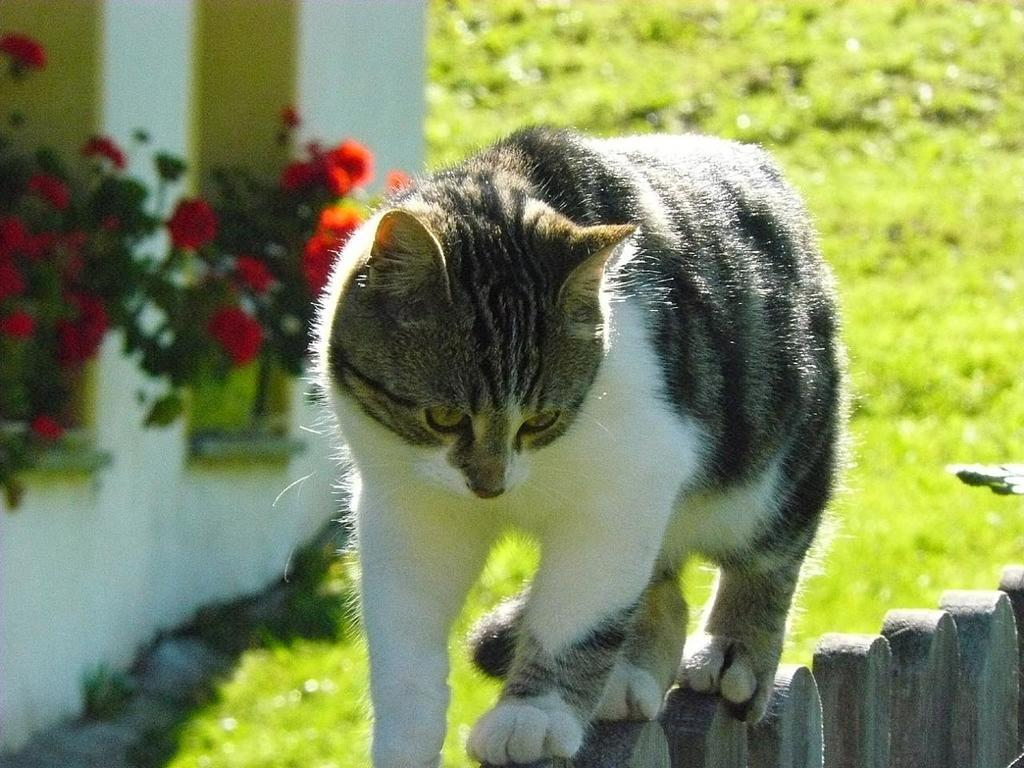What animal can be seen in the foreground of the image? There is a cat on the railing in the foreground of the image. What type of vegetation is visible in the background of the image? There are flowers and plants in the background of the image. What is the background of the image composed of? The background of the image includes a wall, grass, flowers, and plants. What type of fold can be seen in the cat's fur in the image? There is no specific fold visible in the cat's fur in the image. What type of chain is hanging from the wall in the image? There is no chain present in the image. 